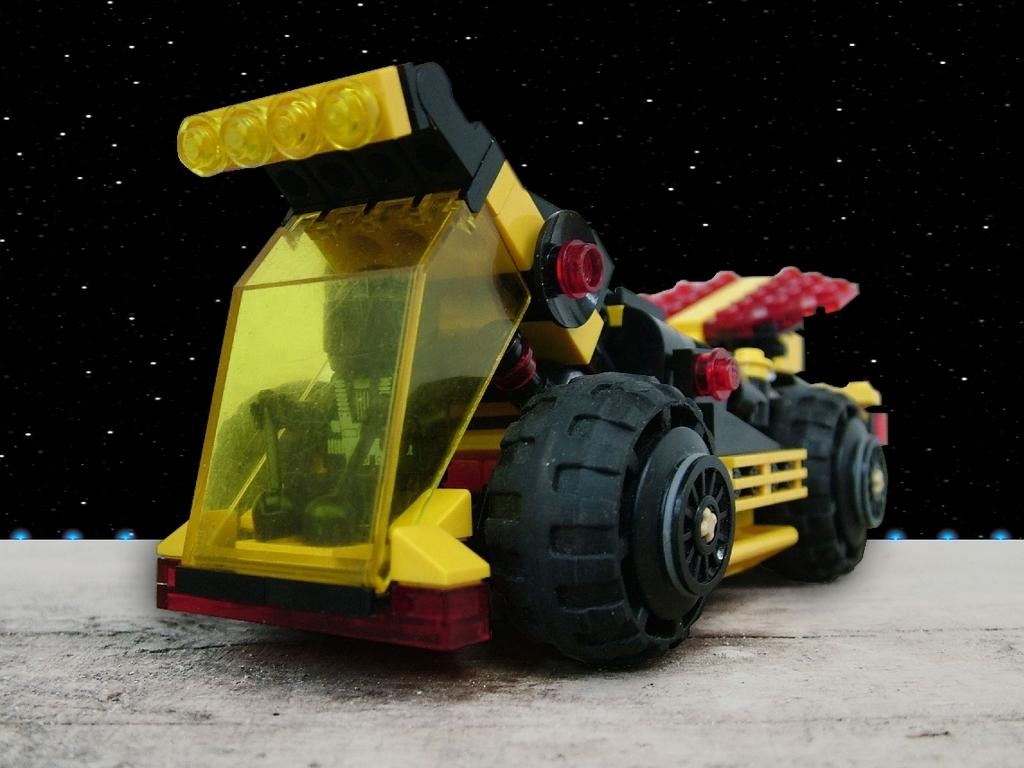What type of object is in the image? There is a toy vehicle in the image. Can you describe the colors of the toy vehicle? The toy vehicle is in yellow, black, and red colors. What type of disease is affecting the family in the image? There is no family present in the image, and therefore no disease can be observed. How tall are the giants in the image? There are no giants present in the image. 